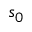<formula> <loc_0><loc_0><loc_500><loc_500>s _ { 0 }</formula> 